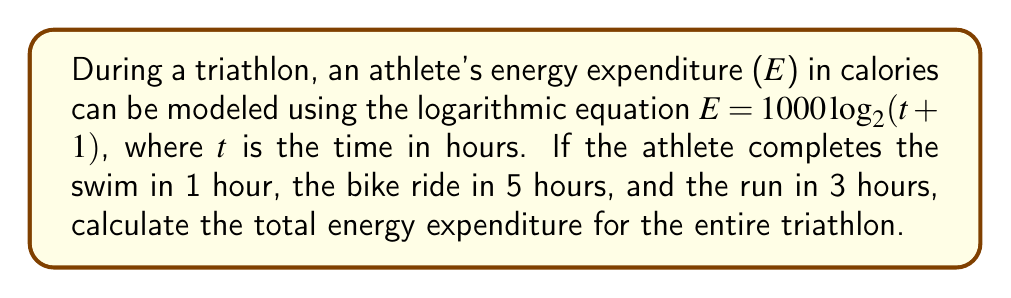What is the answer to this math problem? Let's approach this step-by-step:

1) First, we need to calculate the total time of the triathlon:
   Swim: 1 hour
   Bike: 5 hours
   Run: 3 hours
   Total time: $1 + 5 + 3 = 9$ hours

2) Now, we plug this into our equation:
   $E = 1000 \log_2(t + 1)$
   $E = 1000 \log_2(9 + 1)$
   $E = 1000 \log_2(10)$

3) To calculate $\log_2(10)$, we can use the change of base formula:
   $\log_2(10) = \frac{\log(10)}{\log(2)}$

4) Using a calculator or logarithm table:
   $\log(10) \approx 2.302585$
   $\log(2) \approx 0.693147$

5) Dividing:
   $\frac{2.302585}{0.693147} \approx 3.321928$

6) Now, we multiply by 1000:
   $E = 1000 \cdot 3.321928 \approx 3321.928$

7) Rounding to the nearest calorie:
   $E \approx 3322$ calories
Answer: 3322 calories 